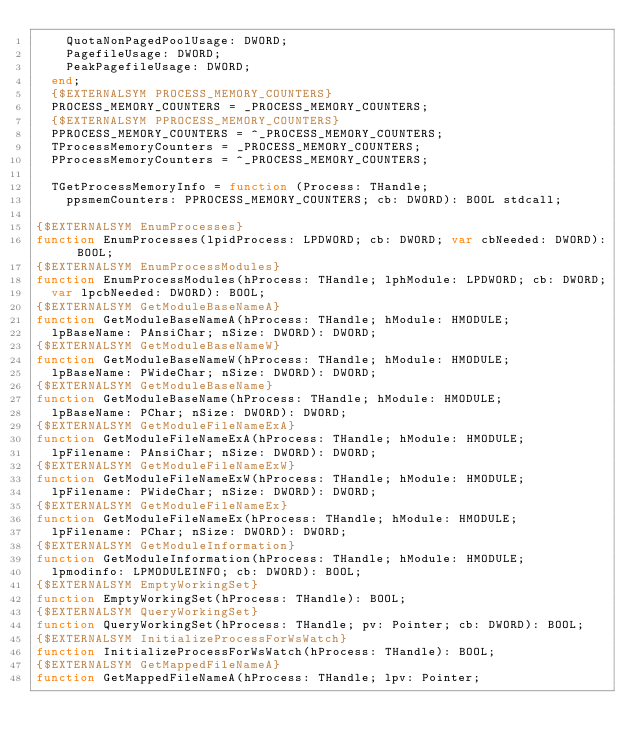Convert code to text. <code><loc_0><loc_0><loc_500><loc_500><_Pascal_>    QuotaNonPagedPoolUsage: DWORD;
    PagefileUsage: DWORD;
    PeakPagefileUsage: DWORD;
  end;
  {$EXTERNALSYM PROCESS_MEMORY_COUNTERS}
  PROCESS_MEMORY_COUNTERS = _PROCESS_MEMORY_COUNTERS;
  {$EXTERNALSYM PPROCESS_MEMORY_COUNTERS}
  PPROCESS_MEMORY_COUNTERS = ^_PROCESS_MEMORY_COUNTERS;
  TProcessMemoryCounters = _PROCESS_MEMORY_COUNTERS;
  PProcessMemoryCounters = ^_PROCESS_MEMORY_COUNTERS;

  TGetProcessMemoryInfo = function (Process: THandle;
    ppsmemCounters: PPROCESS_MEMORY_COUNTERS; cb: DWORD): BOOL stdcall;

{$EXTERNALSYM EnumProcesses}
function EnumProcesses(lpidProcess: LPDWORD; cb: DWORD; var cbNeeded: DWORD): BOOL;
{$EXTERNALSYM EnumProcessModules}
function EnumProcessModules(hProcess: THandle; lphModule: LPDWORD; cb: DWORD;
  var lpcbNeeded: DWORD): BOOL;
{$EXTERNALSYM GetModuleBaseNameA}
function GetModuleBaseNameA(hProcess: THandle; hModule: HMODULE;
  lpBaseName: PAnsiChar; nSize: DWORD): DWORD;
{$EXTERNALSYM GetModuleBaseNameW}
function GetModuleBaseNameW(hProcess: THandle; hModule: HMODULE;
  lpBaseName: PWideChar; nSize: DWORD): DWORD;
{$EXTERNALSYM GetModuleBaseName}
function GetModuleBaseName(hProcess: THandle; hModule: HMODULE;
  lpBaseName: PChar; nSize: DWORD): DWORD;
{$EXTERNALSYM GetModuleFileNameExA}
function GetModuleFileNameExA(hProcess: THandle; hModule: HMODULE;
  lpFilename: PAnsiChar; nSize: DWORD): DWORD;
{$EXTERNALSYM GetModuleFileNameExW}
function GetModuleFileNameExW(hProcess: THandle; hModule: HMODULE;
  lpFilename: PWideChar; nSize: DWORD): DWORD;
{$EXTERNALSYM GetModuleFileNameEx}
function GetModuleFileNameEx(hProcess: THandle; hModule: HMODULE;
  lpFilename: PChar; nSize: DWORD): DWORD;
{$EXTERNALSYM GetModuleInformation}
function GetModuleInformation(hProcess: THandle; hModule: HMODULE;
  lpmodinfo: LPMODULEINFO; cb: DWORD): BOOL;
{$EXTERNALSYM EmptyWorkingSet}
function EmptyWorkingSet(hProcess: THandle): BOOL;
{$EXTERNALSYM QueryWorkingSet}
function QueryWorkingSet(hProcess: THandle; pv: Pointer; cb: DWORD): BOOL;
{$EXTERNALSYM InitializeProcessForWsWatch}
function InitializeProcessForWsWatch(hProcess: THandle): BOOL;
{$EXTERNALSYM GetMappedFileNameA}
function GetMappedFileNameA(hProcess: THandle; lpv: Pointer;</code> 